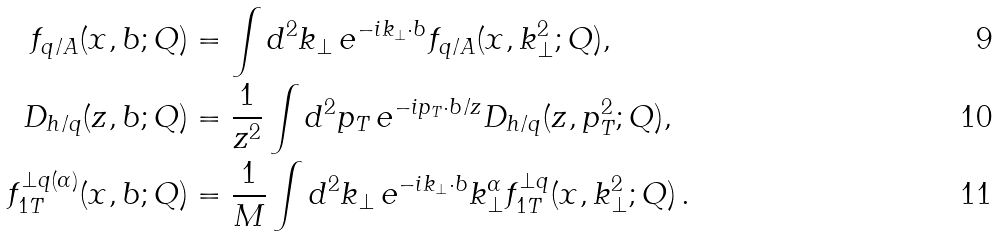<formula> <loc_0><loc_0><loc_500><loc_500>f _ { q / A } ( x , b ; Q ) & = \int d ^ { 2 } k _ { \perp } \, e ^ { - i k _ { \perp } \cdot b } f _ { q / A } ( x , k _ { \perp } ^ { 2 } ; Q ) , \\ D _ { h / q } ( z , b ; Q ) & = \frac { 1 } { z ^ { 2 } } \int d ^ { 2 } p _ { T } \, e ^ { - i p _ { T } \cdot b / z } D _ { h / q } ( z , p _ { T } ^ { 2 } ; Q ) , \\ f _ { 1 T } ^ { \perp q ( \alpha ) } ( x , b ; Q ) & = \frac { 1 } { M } \int d ^ { 2 } k _ { \perp } \, e ^ { - i k _ { \perp } \cdot b } k _ { \perp } ^ { \alpha } f _ { 1 T } ^ { \perp q } ( x , k _ { \perp } ^ { 2 } ; Q ) \, .</formula> 